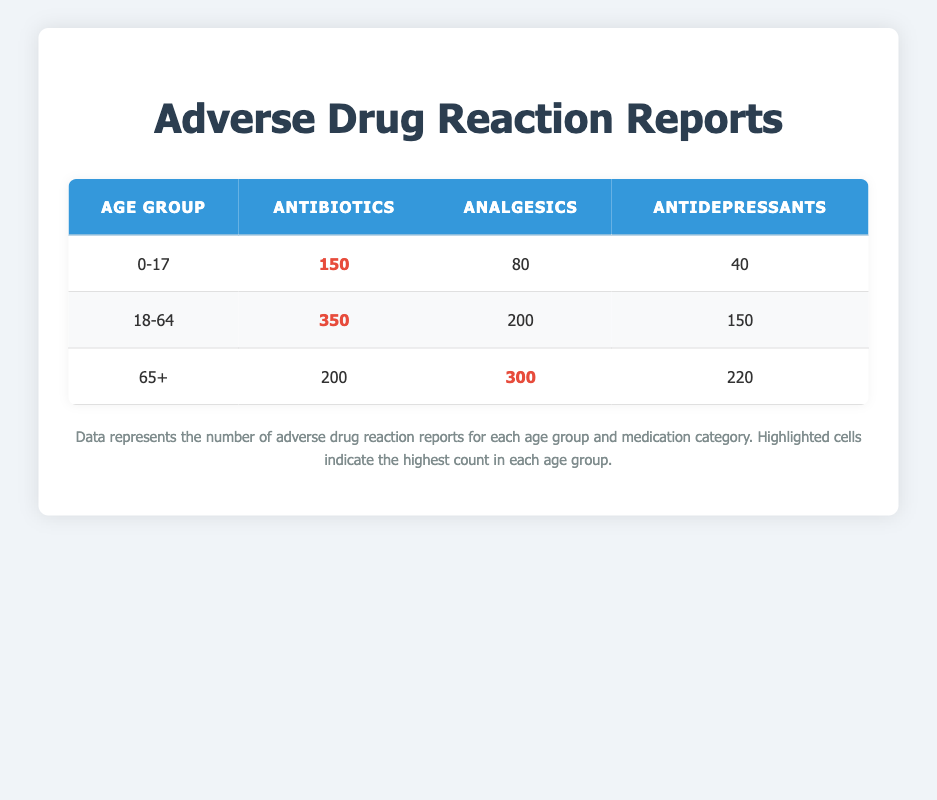What is the total number of adverse drug reactions for the age group 0-17? To find the total number of adverse drug reactions for the age group 0-17, we add the reaction counts for all medication categories listed under this age group: 150 (Antibiotics) + 80 (Analgesics) + 40 (Antidepressants) = 270.
Answer: 270 Which medication category has the highest count of reactions for the age group 18-64? Looking at the age group 18-64, we compare the reaction counts: 350 (Antibiotics), 200 (Analgesics), and 150 (Antidepressants). The highest count is 350 for Antibiotics.
Answer: Antibiotics Is it true that the age group 65+ has more adverse reactions to Analgesics than the 0-17 age group? For the age group 65+, the count for Analgesics is 300, and for the age group 0-17, it is 80. Since 300 is greater than 80, the statement is true.
Answer: Yes What is the average number of adverse drug reactions for Antidepressants across all age groups? To find the average, we first sum up the reaction counts for Antidepressants across all age groups: 40 (0-17) + 150 (18-64) + 220 (65+) = 410. There are 3 age groups, so we divide the total by 3: 410 / 3 = approximately 136.67.
Answer: Approximately 136.67 Which medication category has the lowest total number of adverse reactions across all age groups? We can find this by calculating the total reactions for each category: Antibiotics: 150 + 350 + 200 = 700, Analgesics: 80 + 200 + 300 = 580, Antidepressants: 40 + 150 + 220 = 410. The lowest total is 410 for Antidepressants.
Answer: Antidepressants 